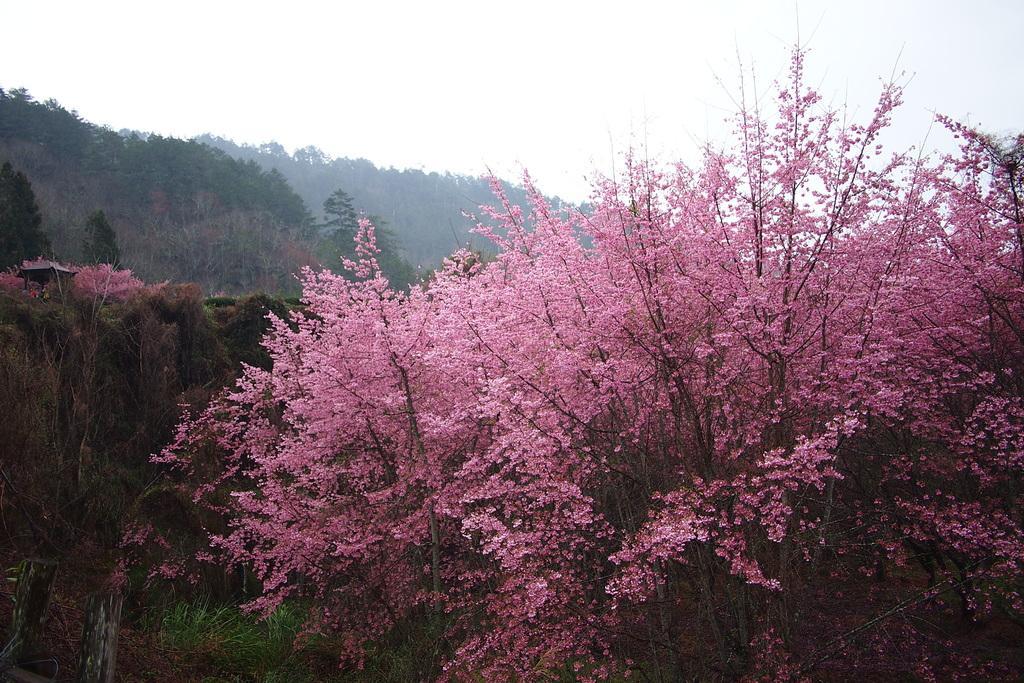Can you describe this image briefly? In the picture I can see some flowers which are pink in color are grown to the trees and in the background of the image there are some trees and clear sky. 